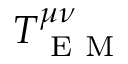Convert formula to latex. <formula><loc_0><loc_0><loc_500><loc_500>T _ { E M } ^ { \mu \nu }</formula> 